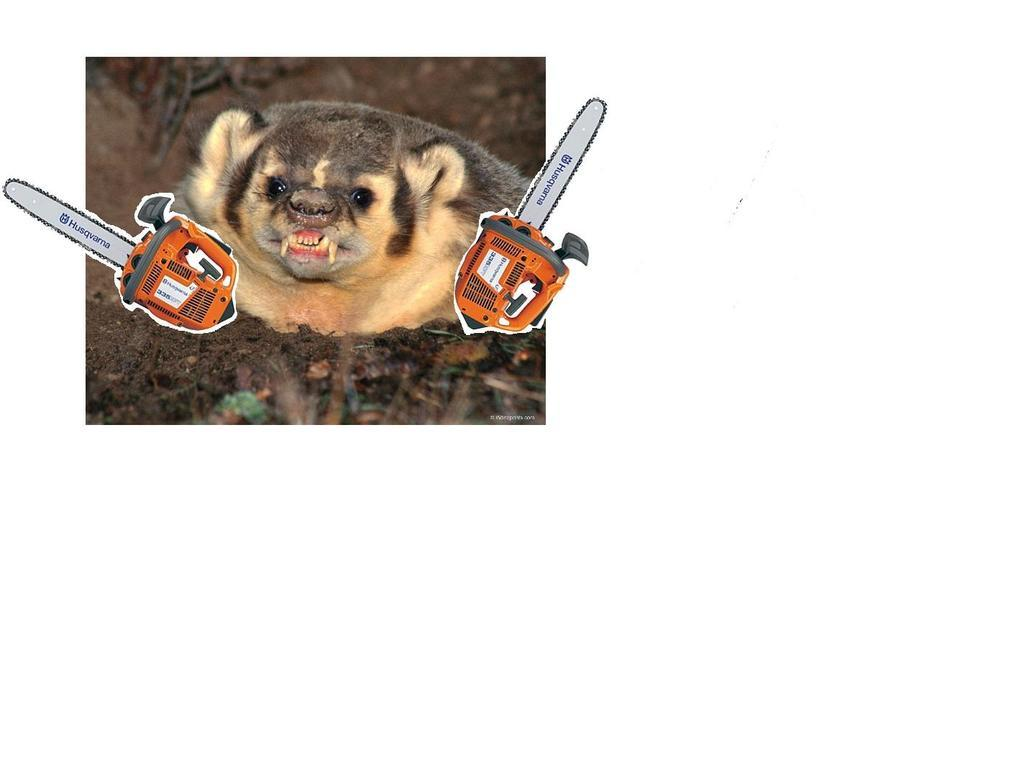What type of animal is in the image? There is a grey and white animal in the image. What objects are also present in the image? There are two chainsaws depicted in the image. What type of silk is being used to create the house in the image? There is no house or silk present in the image; it features a grey and white animal and two chainsaws. 